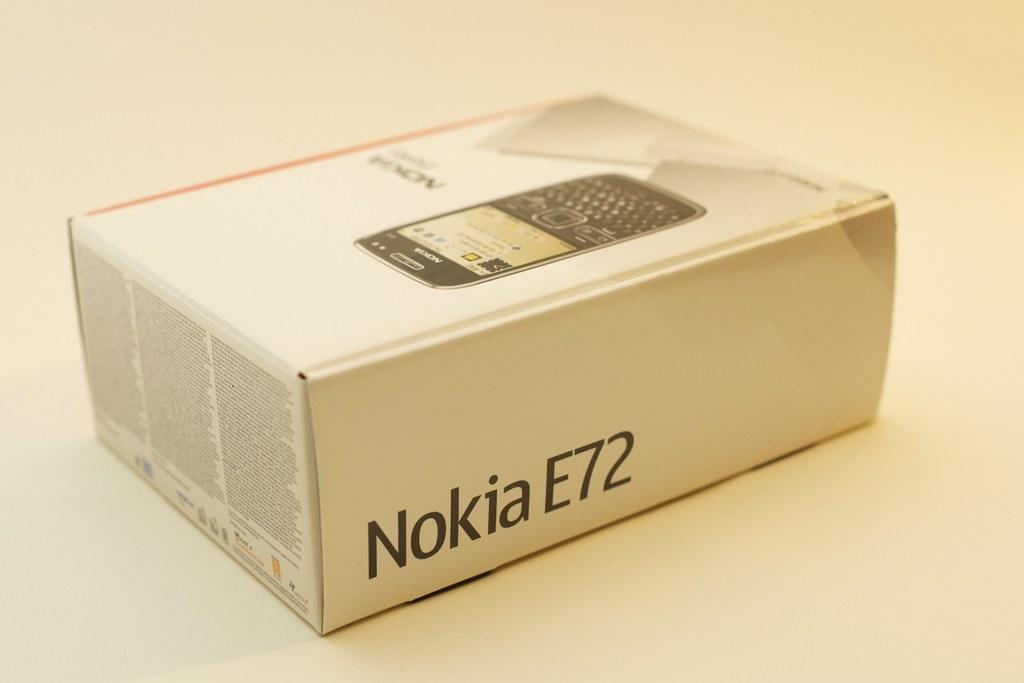What company makes the phone in the box?
Ensure brevity in your answer.  Nokia. What model number is it?
Offer a terse response. E72. 